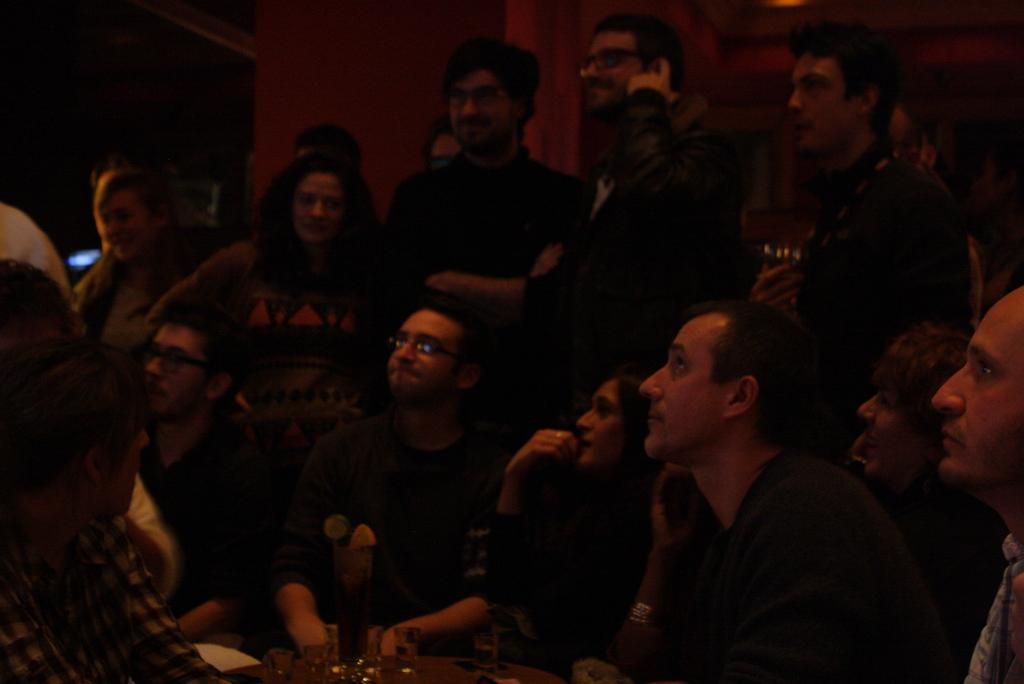What are the people in the image doing? There are people sitting and standing in the image, and they are watching something. Can you describe the background of the image? There is a wall in the background of the image. What type of toothbrush is being used by the people in the image? There is no toothbrush present in the image; the people are watching something. What stage of development can be observed in the image? The provided facts do not mention any developmental stages or processes, so it cannot be determined from the image. 